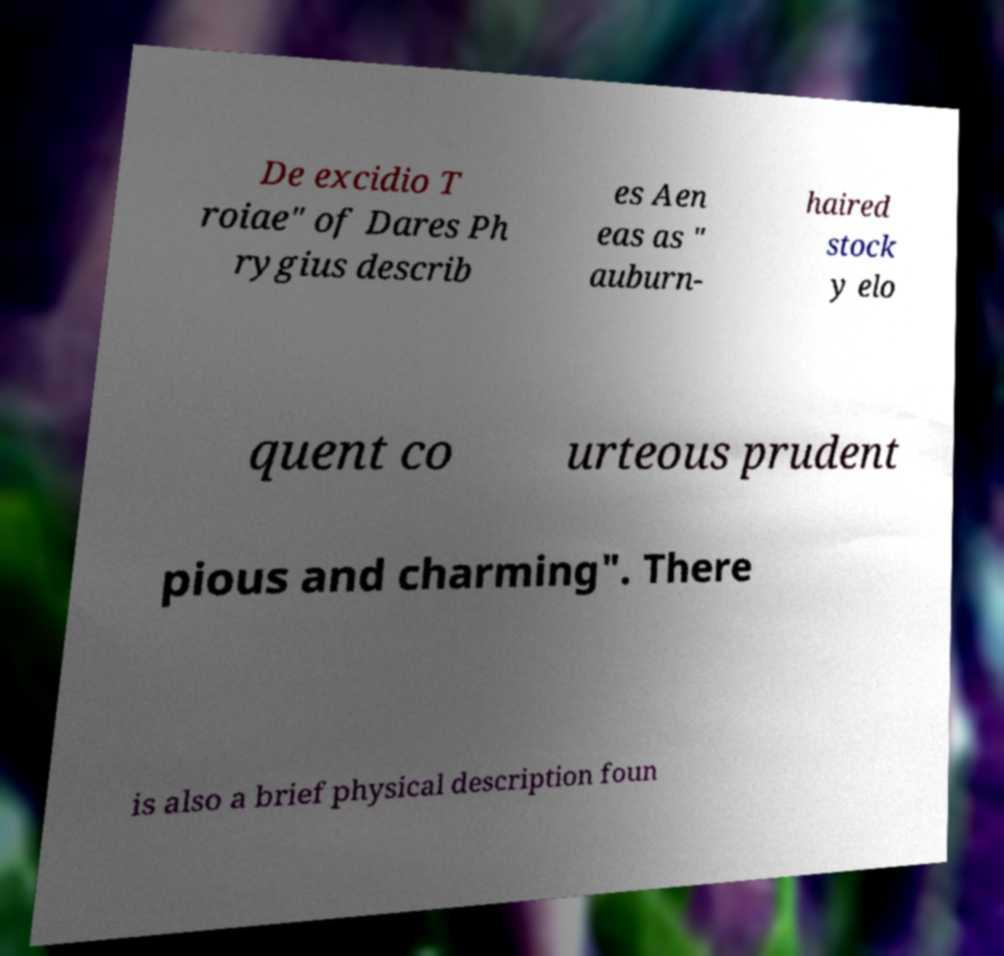Please read and relay the text visible in this image. What does it say? De excidio T roiae" of Dares Ph rygius describ es Aen eas as " auburn- haired stock y elo quent co urteous prudent pious and charming". There is also a brief physical description foun 